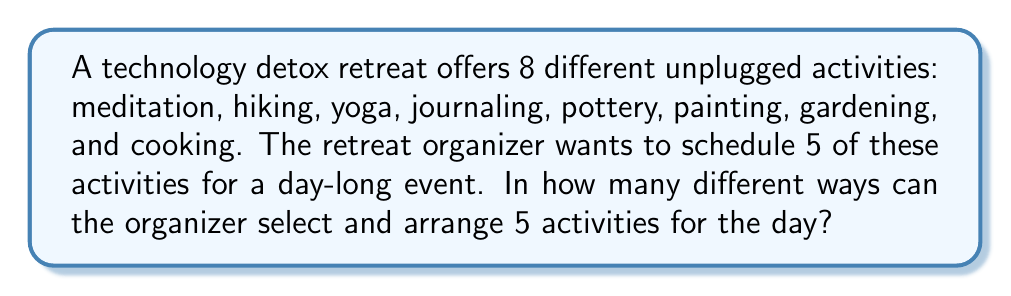Give your solution to this math problem. To solve this problem, we need to use the concept of permutations. We are selecting 5 activities out of 8 and the order matters (as we are arranging them for the day).

1. First, we need to choose 5 activities out of 8. This is a combination problem:
   $$\binom{8}{5} = \frac{8!}{5!(8-5)!} = \frac{8!}{5!3!}$$

2. After selecting 5 activities, we need to arrange them in order. This is a permutation of 5 items:
   $$P(5) = 5!$$

3. By the multiplication principle, the total number of ways to select and arrange 5 activities is:
   $$\binom{8}{5} \times 5!$$

4. Let's calculate:
   $$\binom{8}{5} = \frac{8!}{5!3!} = \frac{8 \times 7 \times 6}{3 \times 2 \times 1} = 56$$

5. Now, multiply by 5!:
   $$56 \times 5! = 56 \times (5 \times 4 \times 3 \times 2 \times 1) = 56 \times 120 = 6,720$$

Therefore, the organizer can select and arrange 5 activities out of 8 in 6,720 different ways.
Answer: 6,720 ways 